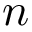<formula> <loc_0><loc_0><loc_500><loc_500>n</formula> 